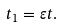Convert formula to latex. <formula><loc_0><loc_0><loc_500><loc_500>t _ { 1 } = \varepsilon t .</formula> 